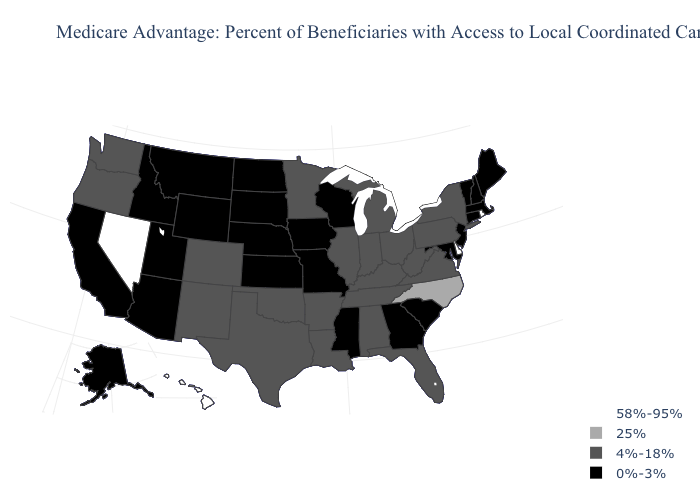What is the value of Maryland?
Short answer required. 0%-3%. How many symbols are there in the legend?
Write a very short answer. 4. Does Oklahoma have the lowest value in the USA?
Quick response, please. No. What is the value of California?
Keep it brief. 0%-3%. Among the states that border Oregon , which have the highest value?
Be succinct. Nevada. Name the states that have a value in the range 25%?
Answer briefly. North Carolina. Among the states that border New Mexico , which have the lowest value?
Concise answer only. Arizona, Utah. Is the legend a continuous bar?
Write a very short answer. No. What is the value of Washington?
Answer briefly. 4%-18%. What is the highest value in the West ?
Short answer required. 58%-95%. Which states have the lowest value in the USA?
Write a very short answer. Alaska, Arizona, California, Connecticut, Georgia, Iowa, Idaho, Kansas, Massachusetts, Maryland, Maine, Missouri, Mississippi, Montana, North Dakota, Nebraska, New Hampshire, New Jersey, South Carolina, South Dakota, Utah, Vermont, Wisconsin, Wyoming. Does Montana have the lowest value in the USA?
Short answer required. Yes. Name the states that have a value in the range 0%-3%?
Quick response, please. Alaska, Arizona, California, Connecticut, Georgia, Iowa, Idaho, Kansas, Massachusetts, Maryland, Maine, Missouri, Mississippi, Montana, North Dakota, Nebraska, New Hampshire, New Jersey, South Carolina, South Dakota, Utah, Vermont, Wisconsin, Wyoming. Among the states that border Virginia , does Tennessee have the highest value?
Be succinct. No. Among the states that border Washington , which have the highest value?
Short answer required. Oregon. 